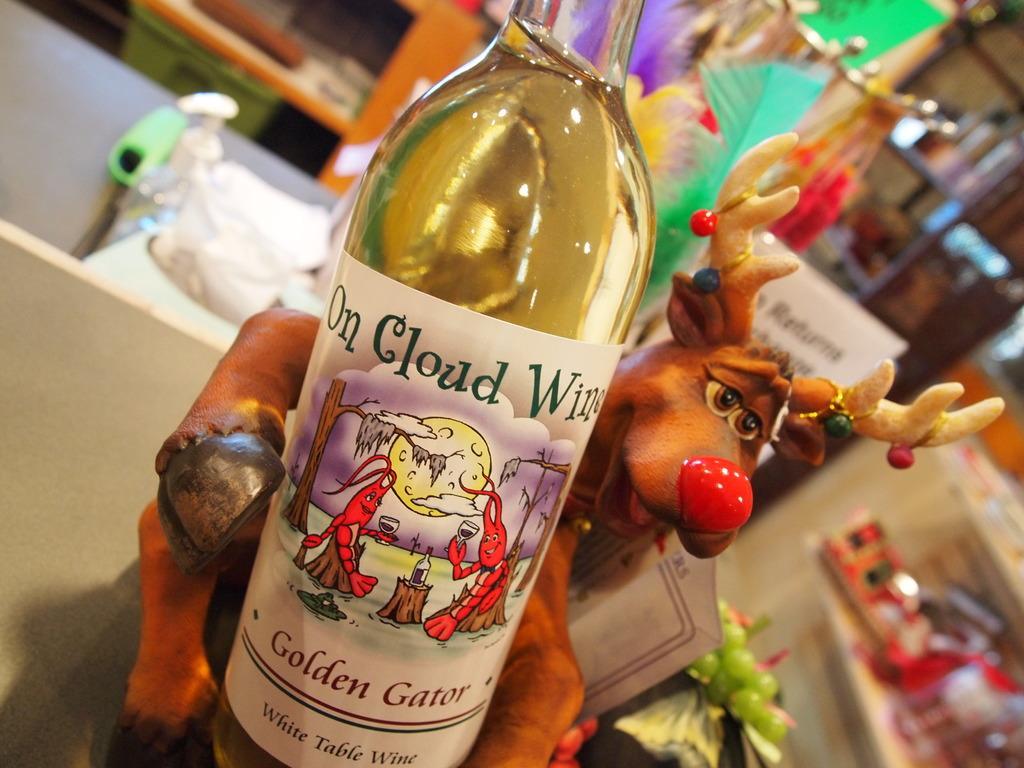Can you describe this image briefly? A bottle with a label is kept on a table. In the back of the bottle there is a toy. Also in the background there are toy grapes, feathers, cupboards. 